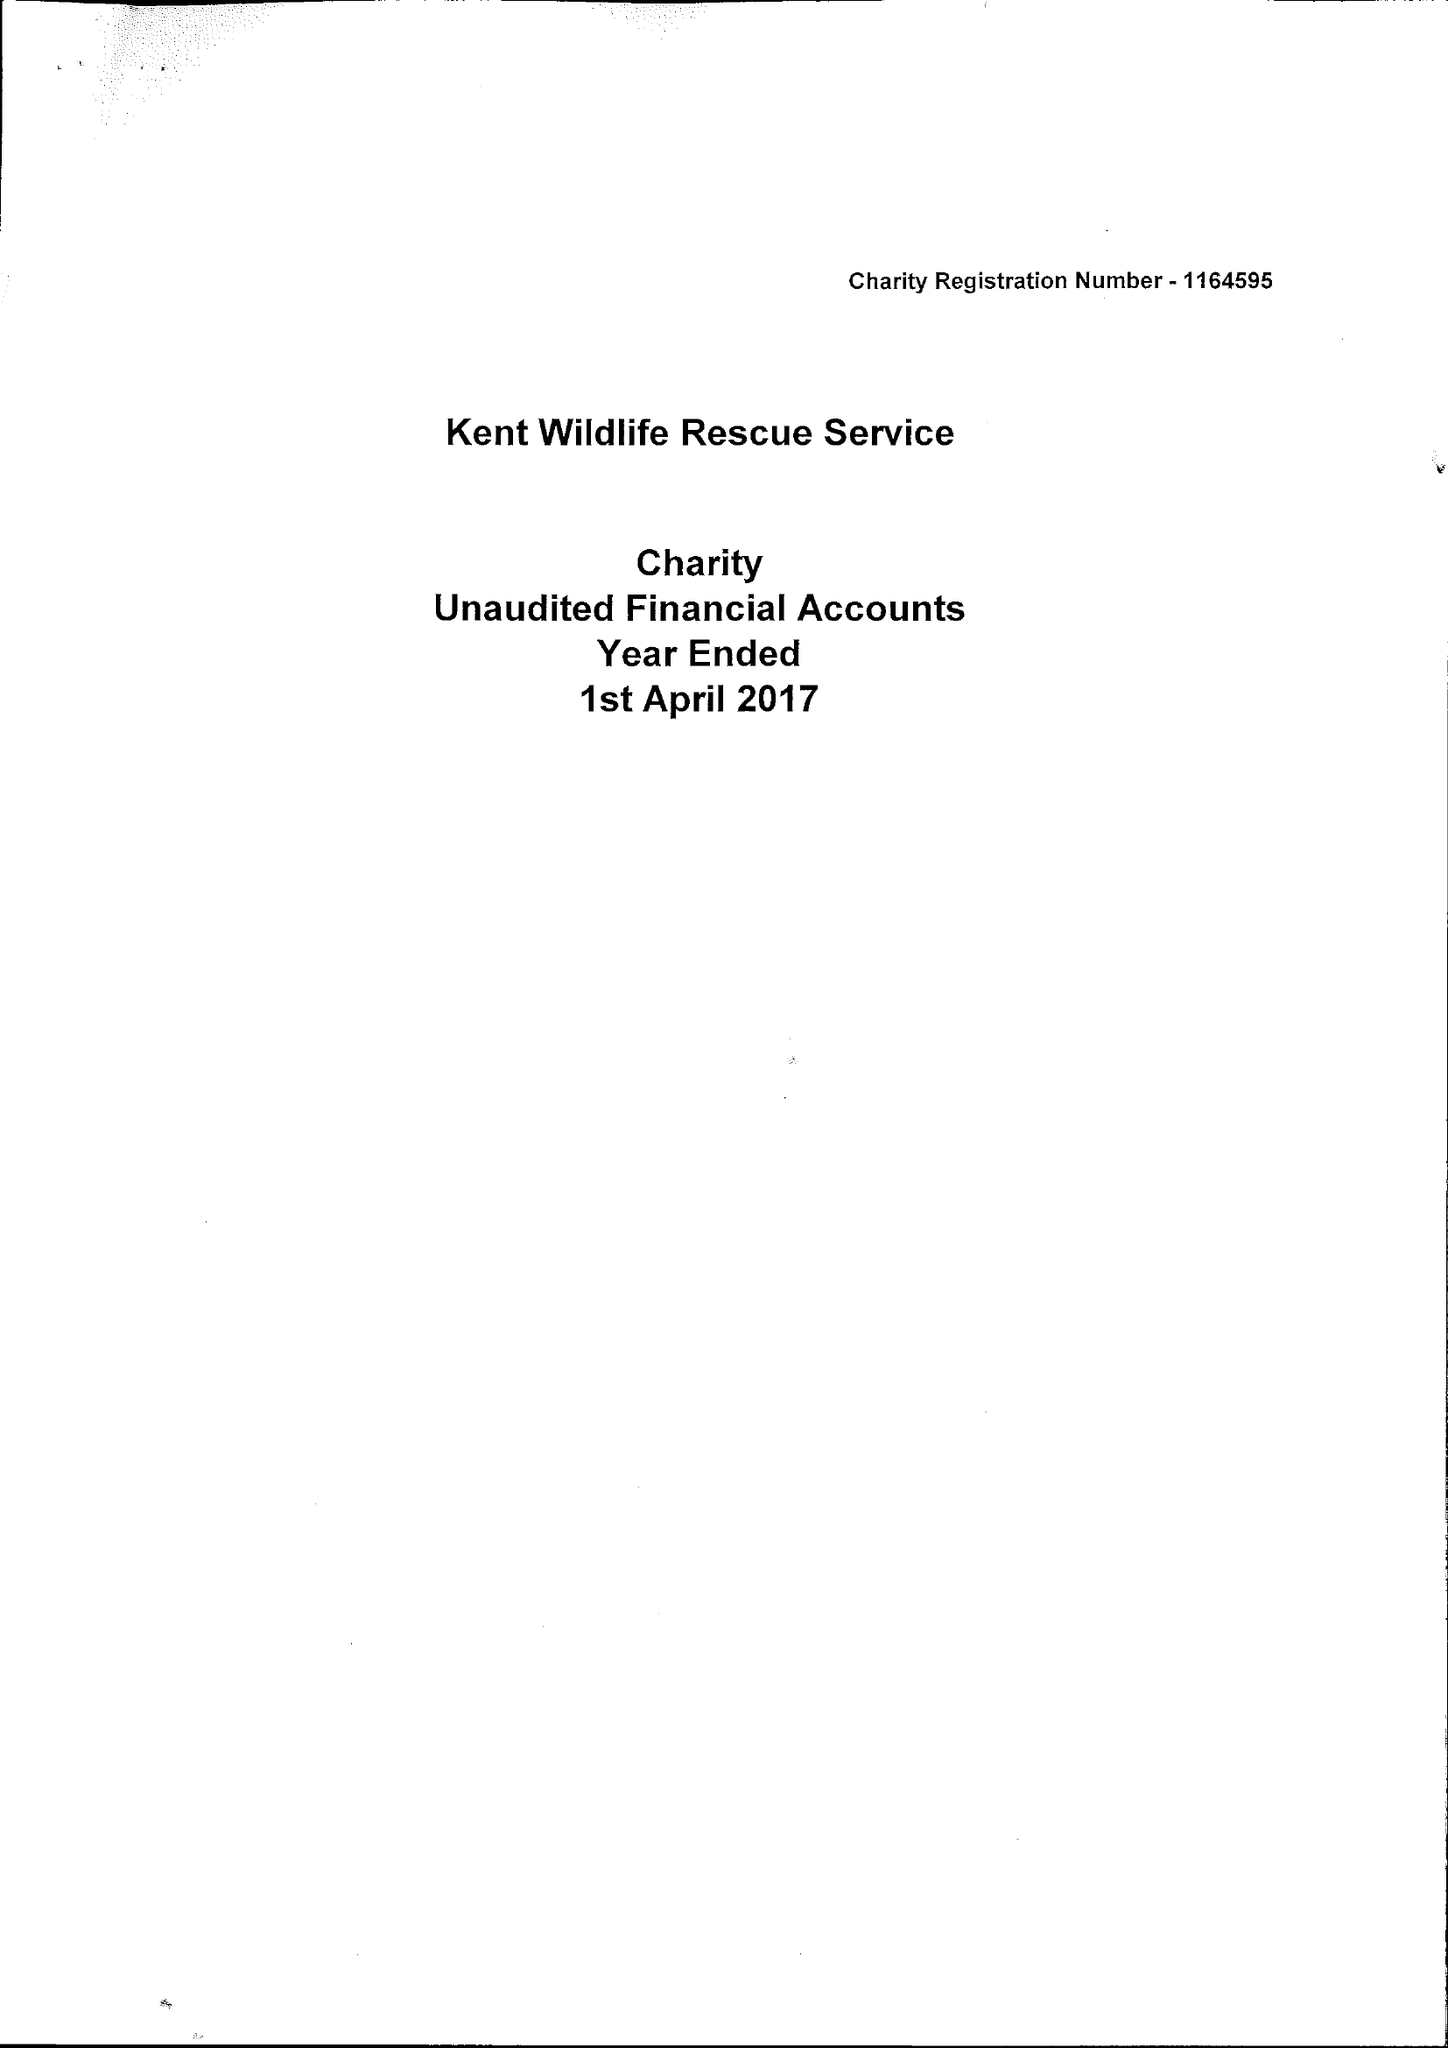What is the value for the spending_annually_in_british_pounds?
Answer the question using a single word or phrase. 14666.00 